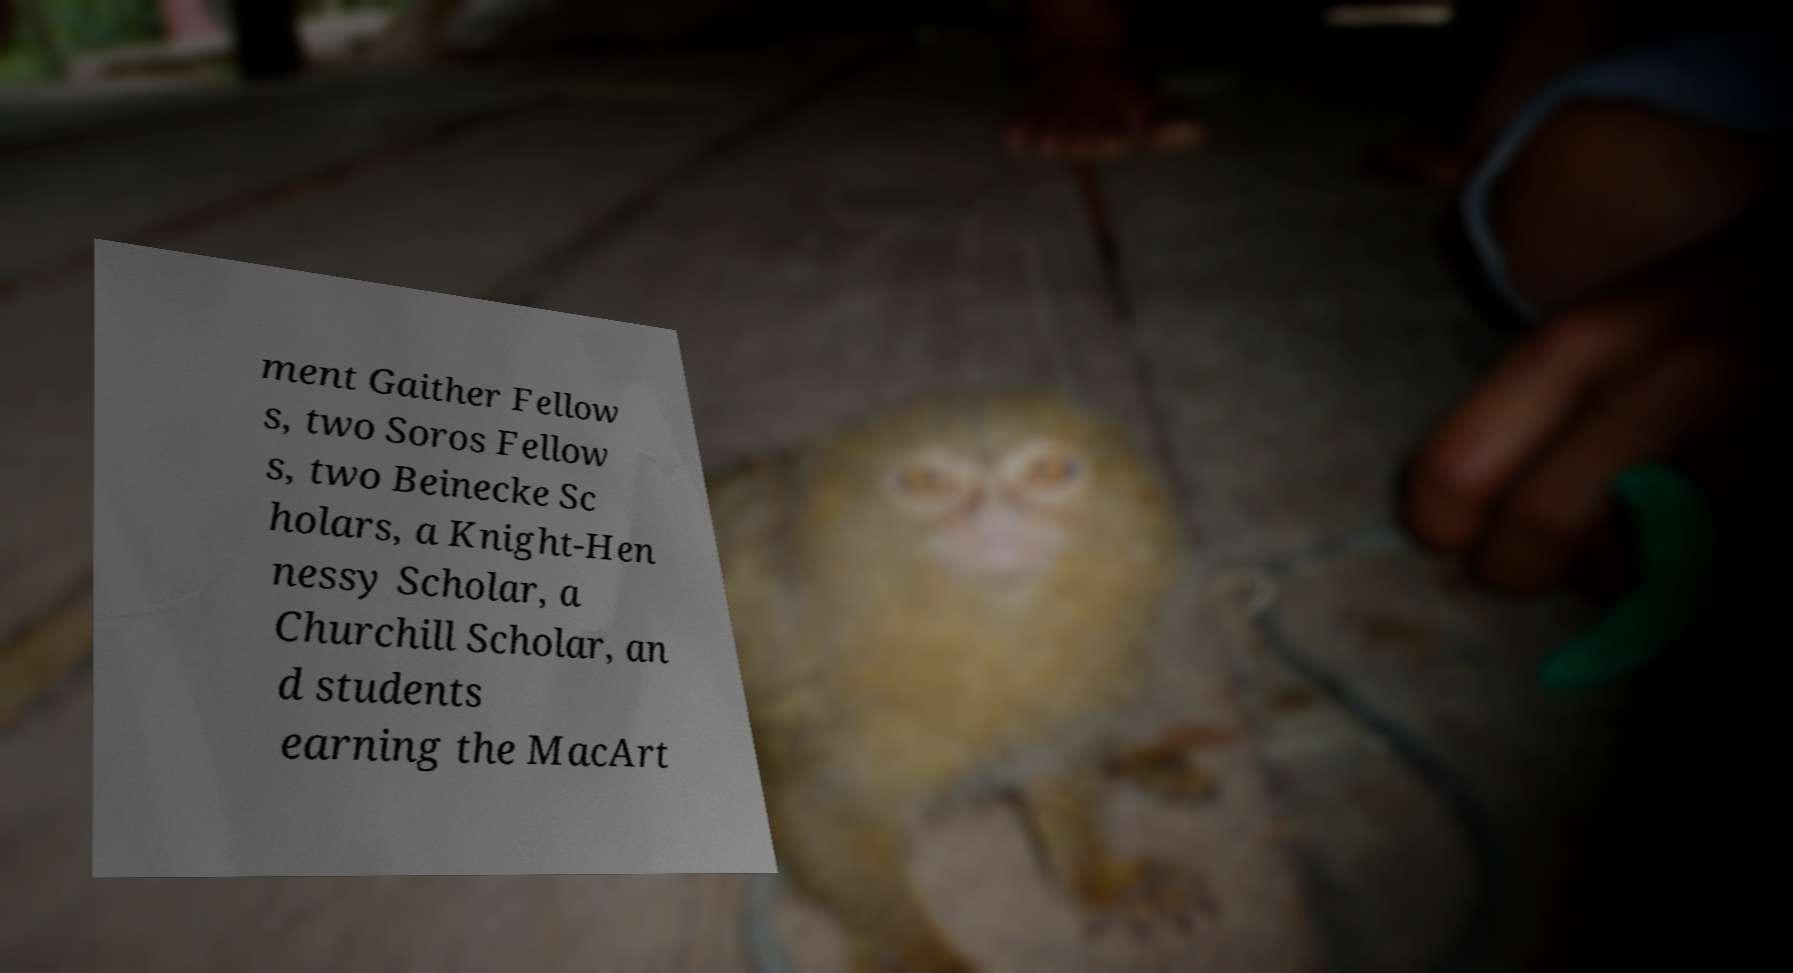Please identify and transcribe the text found in this image. ment Gaither Fellow s, two Soros Fellow s, two Beinecke Sc holars, a Knight-Hen nessy Scholar, a Churchill Scholar, an d students earning the MacArt 